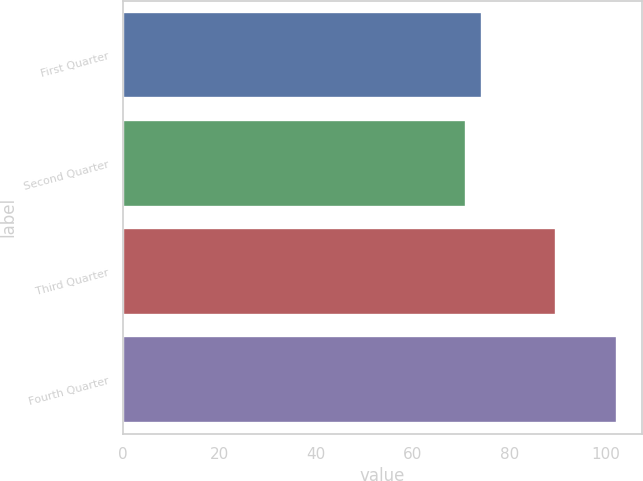Convert chart to OTSL. <chart><loc_0><loc_0><loc_500><loc_500><bar_chart><fcel>First Quarter<fcel>Second Quarter<fcel>Third Quarter<fcel>Fourth Quarter<nl><fcel>74.24<fcel>71.12<fcel>89.66<fcel>102.33<nl></chart> 